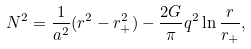Convert formula to latex. <formula><loc_0><loc_0><loc_500><loc_500>N ^ { 2 } = \frac { 1 } { a ^ { 2 } } ( r ^ { 2 } - r _ { + } ^ { 2 } ) - \frac { 2 G } { \pi } q ^ { 2 } \ln \frac { r } { r _ { + } } ,</formula> 